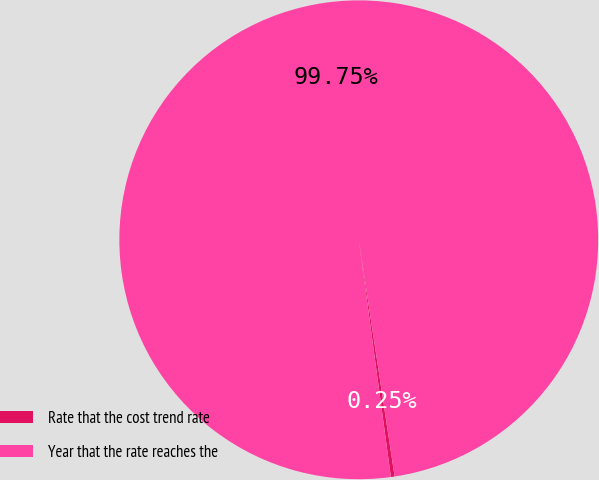Convert chart. <chart><loc_0><loc_0><loc_500><loc_500><pie_chart><fcel>Rate that the cost trend rate<fcel>Year that the rate reaches the<nl><fcel>0.25%<fcel>99.75%<nl></chart> 